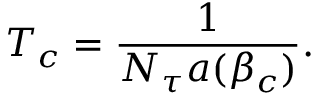<formula> <loc_0><loc_0><loc_500><loc_500>T _ { c } = { \frac { 1 } { N _ { \tau } a ( \beta _ { c } ) } } .</formula> 